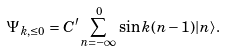<formula> <loc_0><loc_0><loc_500><loc_500>\Psi _ { k , \leq 0 } = C ^ { \prime } \sum _ { n = - \infty } ^ { 0 } \sin k ( n - 1 ) | n \rangle .</formula> 